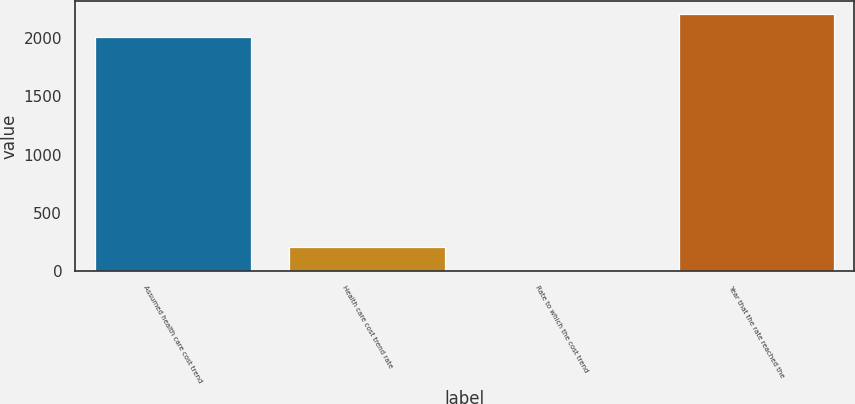<chart> <loc_0><loc_0><loc_500><loc_500><bar_chart><fcel>Assumed health care cost trend<fcel>Health care cost trend rate<fcel>Rate to which the cost trend<fcel>Year that the rate reached the<nl><fcel>2003<fcel>205.3<fcel>5<fcel>2203.3<nl></chart> 